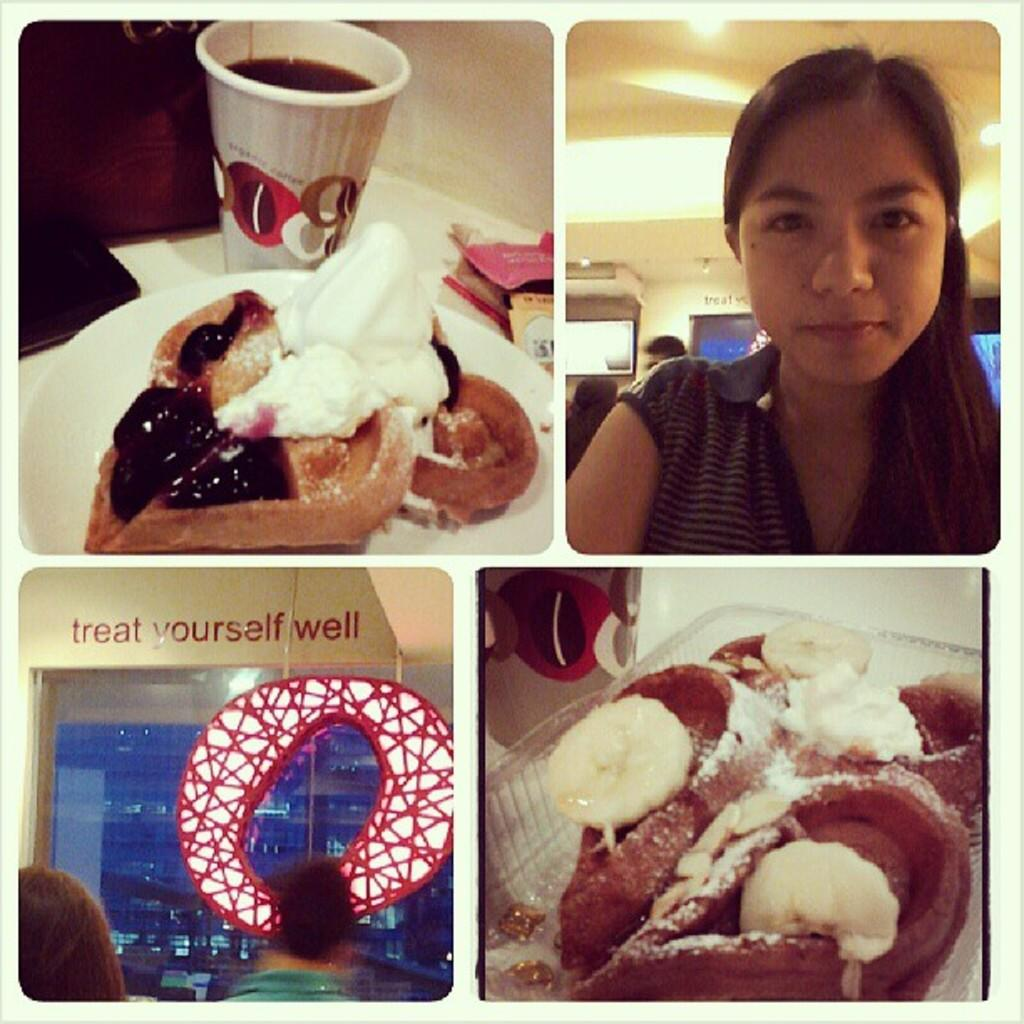What is on the plate in the image? There is a food item on a plate in the image, and it has cream on it. What else can be seen on the table in the image? There is a glass on the table in the image. Who is present in the image? A woman is standing in the image. What can be seen providing illumination in the image? There is a light visible in the image. What story is the woman reading from the books in the image? There are no books present in the image, so no story can be read. 